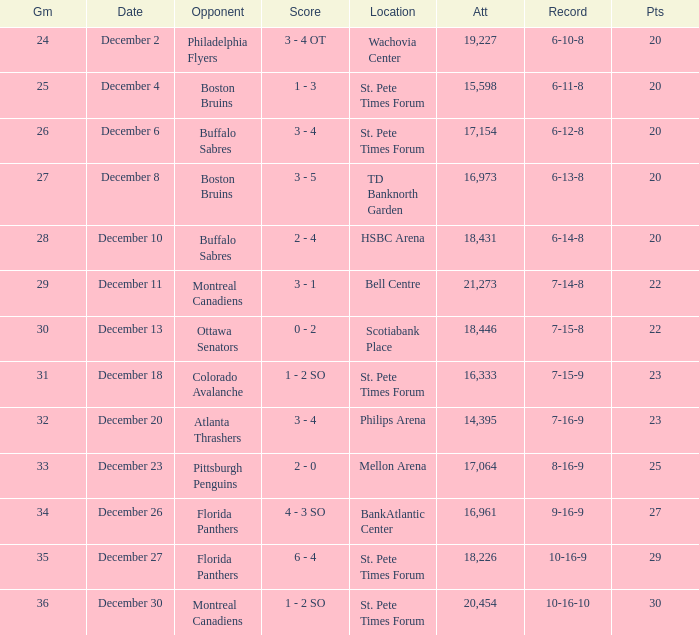What game has a 6-12-8 record? 26.0. 